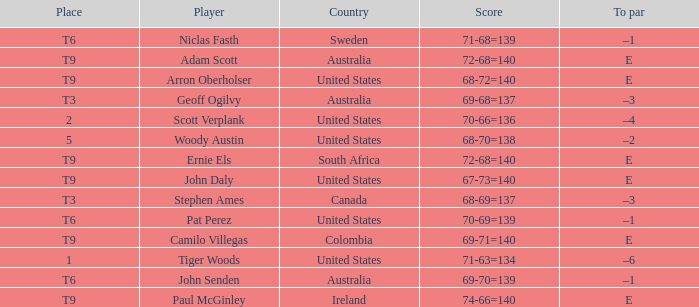Which player is from Sweden? Niclas Fasth. 